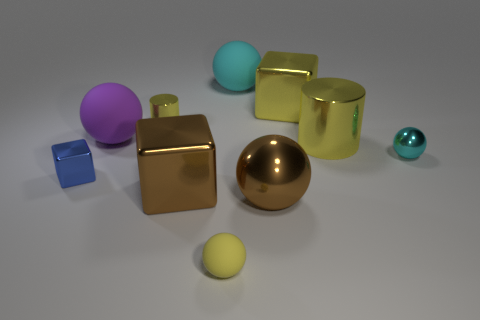Subtract all yellow spheres. How many spheres are left? 4 Subtract all large metal balls. How many balls are left? 4 Subtract all green balls. Subtract all yellow cylinders. How many balls are left? 5 Subtract all cylinders. How many objects are left? 8 Add 3 large yellow metal cubes. How many large yellow metal cubes exist? 4 Subtract 0 cyan blocks. How many objects are left? 10 Subtract all blue metal objects. Subtract all brown shiny things. How many objects are left? 7 Add 7 cyan spheres. How many cyan spheres are left? 9 